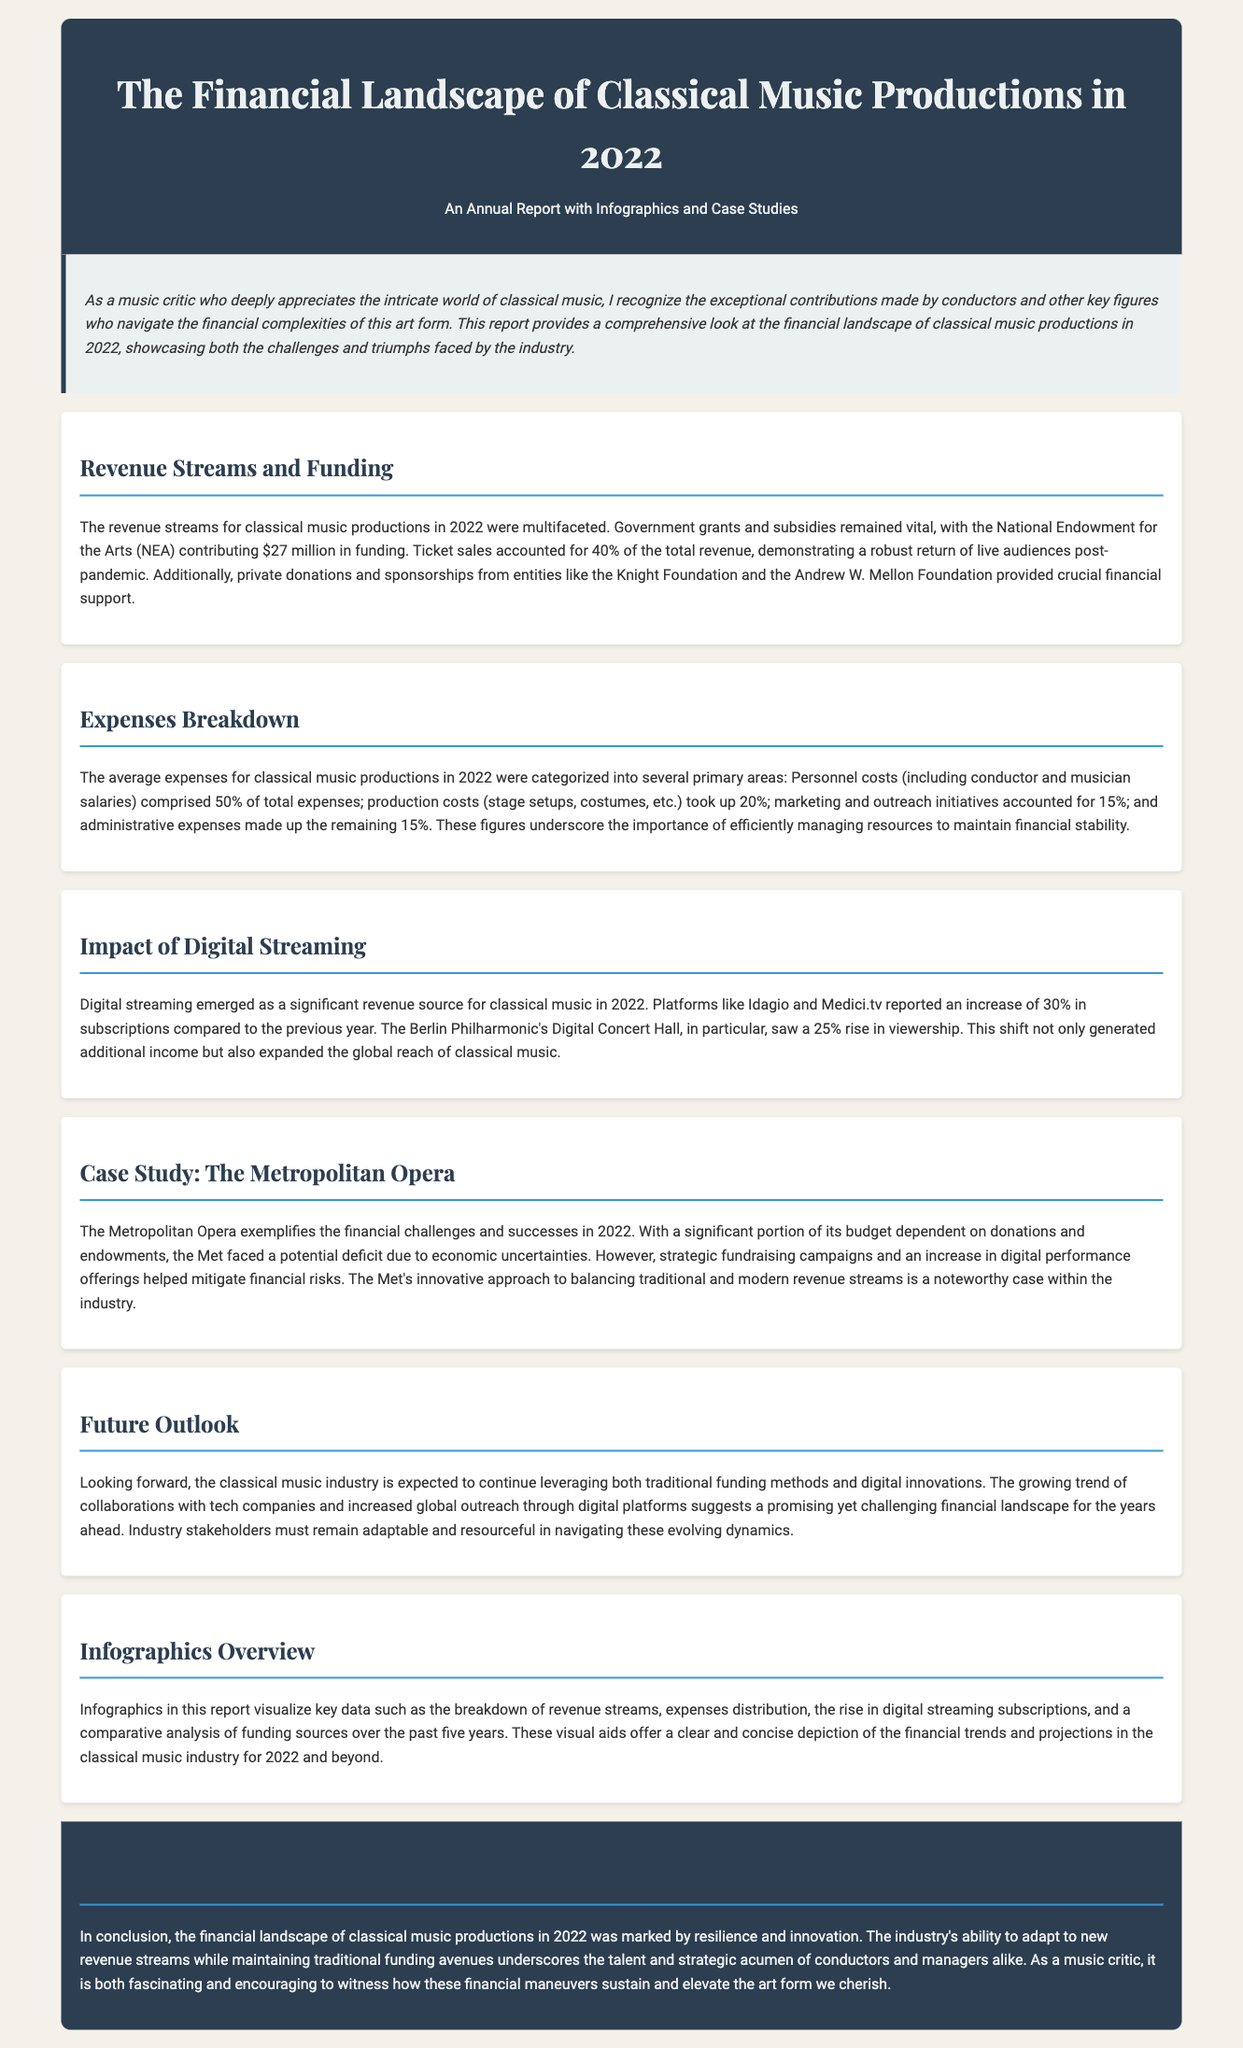What was the NEA funding amount in 2022? The document states that the National Endowment for the Arts contributed $27 million in funding in 2022.
Answer: $27 million What percentage of total revenue came from ticket sales? According to the report, ticket sales accounted for 40% of the total revenue.
Answer: 40% What is the largest expense category for classical music productions? The document indicates that personnel costs (including conductor and musician salaries) comprised 50% of total expenses.
Answer: 50% How much did digital streaming subscriptions increase by in 2022? Digital streaming subscriptions saw an increase of 30% compared to the previous year.
Answer: 30% What innovative approach did The Metropolitan Opera take in 2022? The document describes how the Met implemented strategic fundraising campaigns and increased digital performance offerings to mitigate financial risks.
Answer: Strategic fundraising and digital performance What tool is used in the report to visualize key data? Infographics are used to visualize key data such as revenue streams and expenses distribution.
Answer: Infographics What does the future outlook suggest for the classical music industry? The outlook suggests that the industry will leverage both traditional funding methods and digital innovations.
Answer: Traditional and digital innovations What percentage of expenses was allocated to marketing and outreach? The report states that marketing and outreach initiatives accounted for 15% of total expenses.
Answer: 15% 